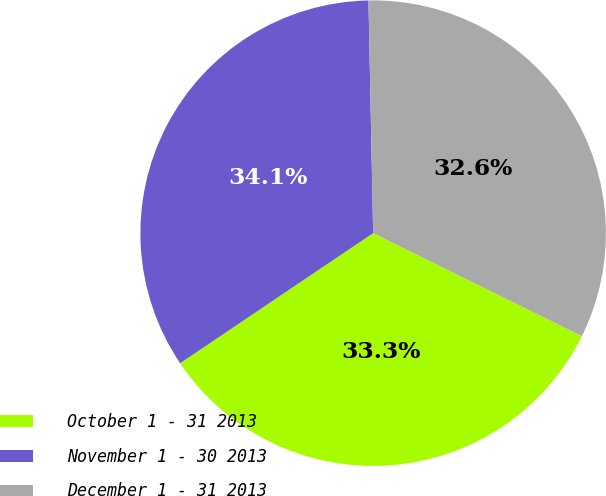Convert chart. <chart><loc_0><loc_0><loc_500><loc_500><pie_chart><fcel>October 1 - 31 2013<fcel>November 1 - 30 2013<fcel>December 1 - 31 2013<nl><fcel>33.27%<fcel>34.12%<fcel>32.62%<nl></chart> 